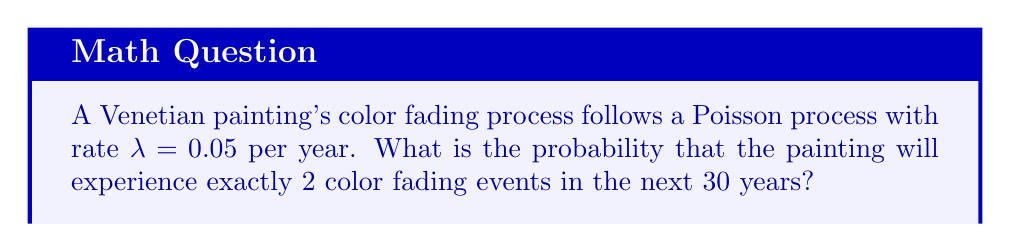What is the answer to this math problem? To solve this problem, we'll use the Poisson distribution formula:

$$P(X = k) = \frac{e^{-\lambda t}(\lambda t)^k}{k!}$$

Where:
$X$ is the number of events
$k$ is the specific number of events we're interested in
$\lambda$ is the rate parameter
$t$ is the time interval

Given:
$\lambda = 0.05$ per year
$t = 30$ years
$k = 2$ events

Step 1: Calculate $\lambda t$
$\lambda t = 0.05 \times 30 = 1.5$

Step 2: Substitute values into the Poisson distribution formula
$$P(X = 2) = \frac{e^{-1.5}(1.5)^2}{2!}$$

Step 3: Evaluate the expression
$$P(X = 2) = \frac{e^{-1.5} \times 2.25}{2}$$
$$P(X = 2) = \frac{0.2231 \times 2.25}{2}$$
$$P(X = 2) = 0.2510$$

Therefore, the probability of exactly 2 color fading events occurring in the next 30 years is approximately 0.2510 or 25.10%.
Answer: 0.2510 